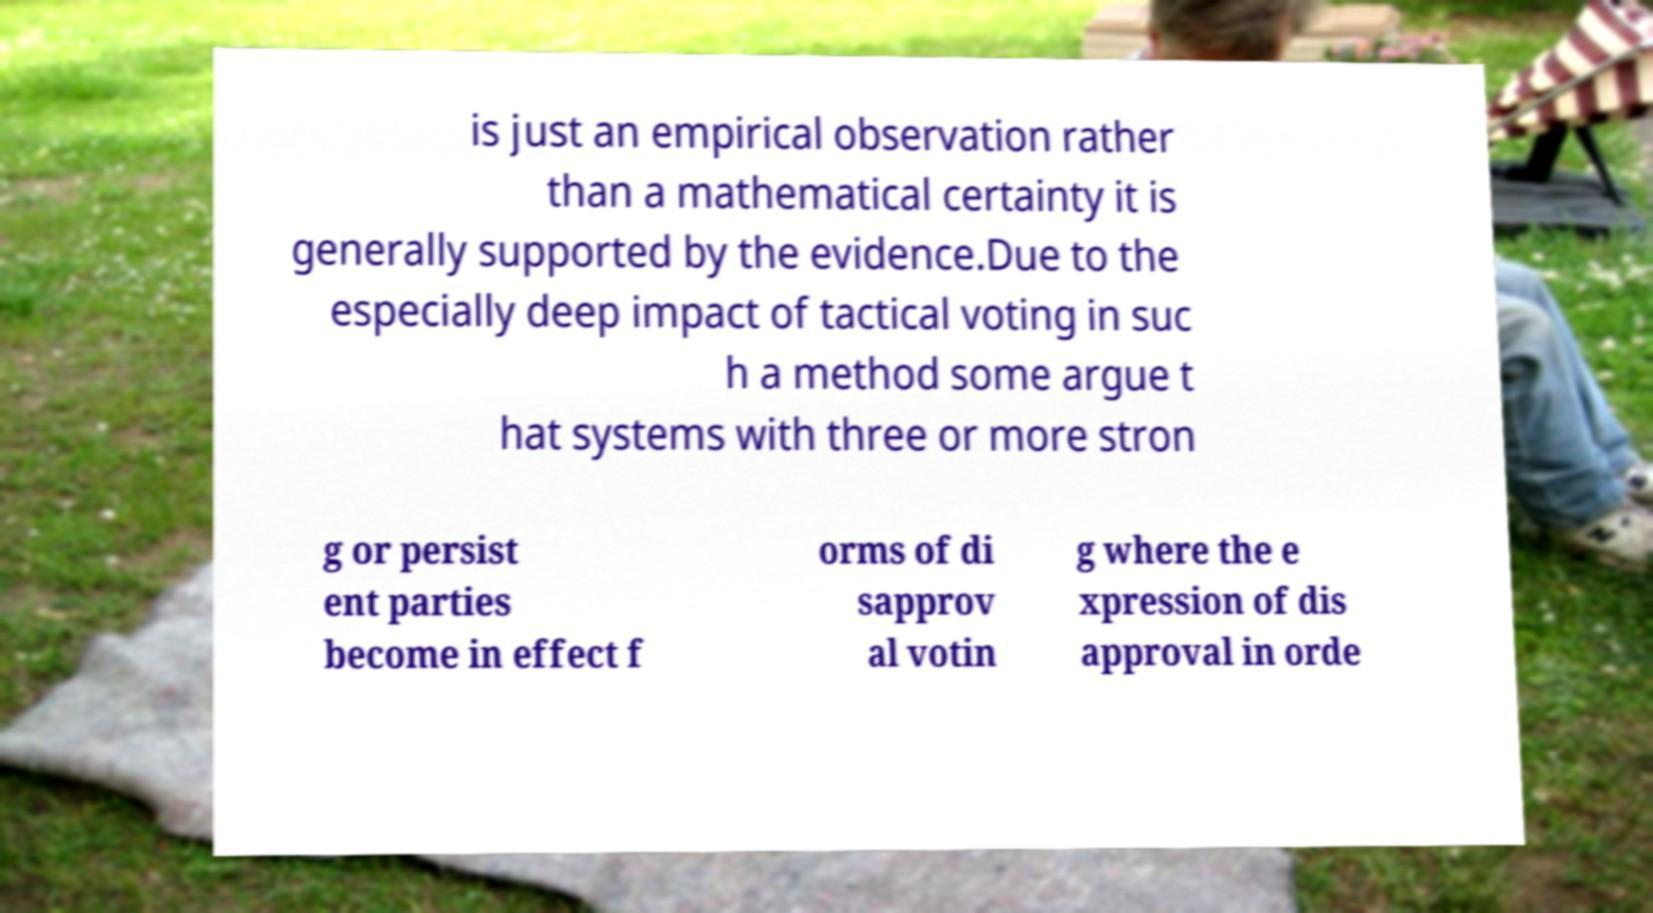What messages or text are displayed in this image? I need them in a readable, typed format. is just an empirical observation rather than a mathematical certainty it is generally supported by the evidence.Due to the especially deep impact of tactical voting in suc h a method some argue t hat systems with three or more stron g or persist ent parties become in effect f orms of di sapprov al votin g where the e xpression of dis approval in orde 